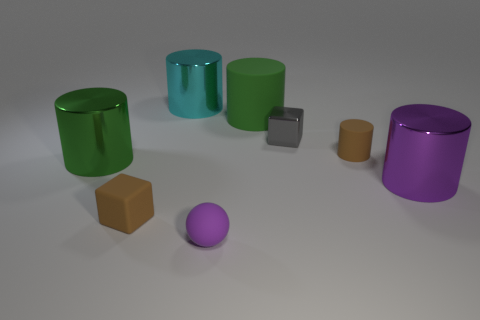Subtract all cyan cylinders. How many cylinders are left? 4 Subtract all tiny brown rubber cylinders. How many cylinders are left? 4 Subtract all blue cylinders. Subtract all yellow balls. How many cylinders are left? 5 Add 2 balls. How many objects exist? 10 Subtract all balls. How many objects are left? 7 Subtract all big blue metal things. Subtract all tiny brown blocks. How many objects are left? 7 Add 4 tiny metallic cubes. How many tiny metallic cubes are left? 5 Add 3 purple shiny balls. How many purple shiny balls exist? 3 Subtract 1 gray cubes. How many objects are left? 7 